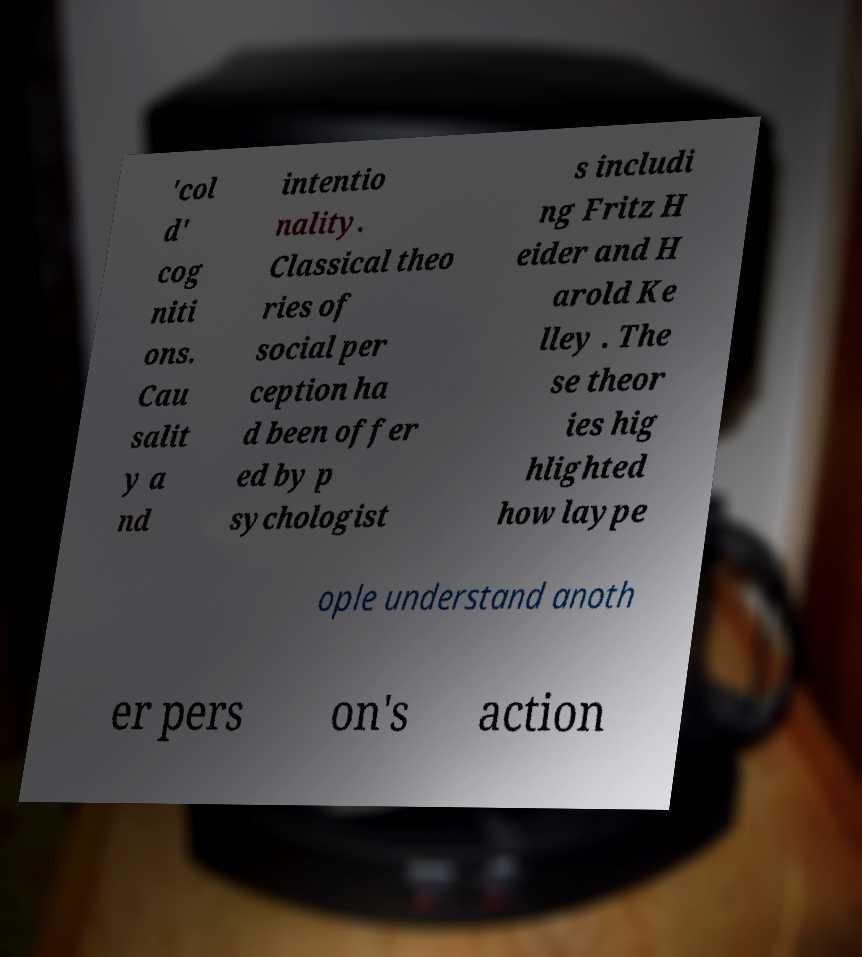Can you read and provide the text displayed in the image?This photo seems to have some interesting text. Can you extract and type it out for me? 'col d' cog niti ons. Cau salit y a nd intentio nality. Classical theo ries of social per ception ha d been offer ed by p sychologist s includi ng Fritz H eider and H arold Ke lley . The se theor ies hig hlighted how laype ople understand anoth er pers on's action 